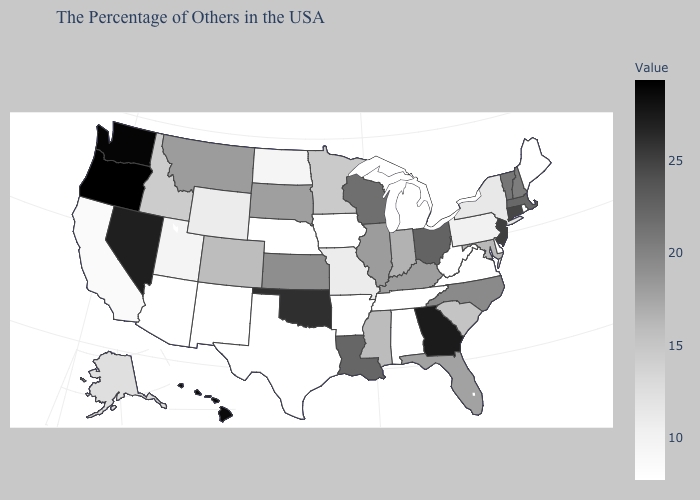Among the states that border Minnesota , which have the lowest value?
Concise answer only. Iowa. Does the map have missing data?
Keep it brief. No. Which states hav the highest value in the MidWest?
Be succinct. Ohio. Which states have the lowest value in the West?
Concise answer only. New Mexico, Arizona. Among the states that border Oregon , does California have the lowest value?
Quick response, please. Yes. Which states hav the highest value in the South?
Write a very short answer. Georgia. Does Kentucky have a lower value than West Virginia?
Short answer required. No. Which states hav the highest value in the West?
Be succinct. Oregon. 